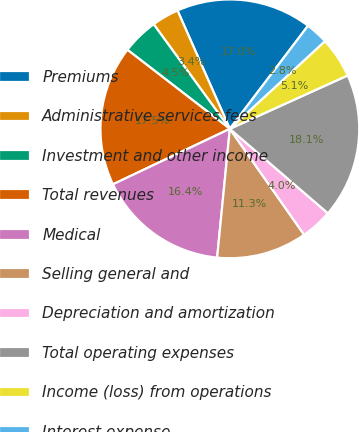<chart> <loc_0><loc_0><loc_500><loc_500><pie_chart><fcel>Premiums<fcel>Administrative services fees<fcel>Investment and other income<fcel>Total revenues<fcel>Medical<fcel>Selling general and<fcel>Depreciation and amortization<fcel>Total operating expenses<fcel>Income (loss) from operations<fcel>Interest expense<nl><fcel>16.95%<fcel>3.39%<fcel>4.52%<fcel>17.51%<fcel>16.38%<fcel>11.3%<fcel>3.95%<fcel>18.08%<fcel>5.08%<fcel>2.82%<nl></chart> 